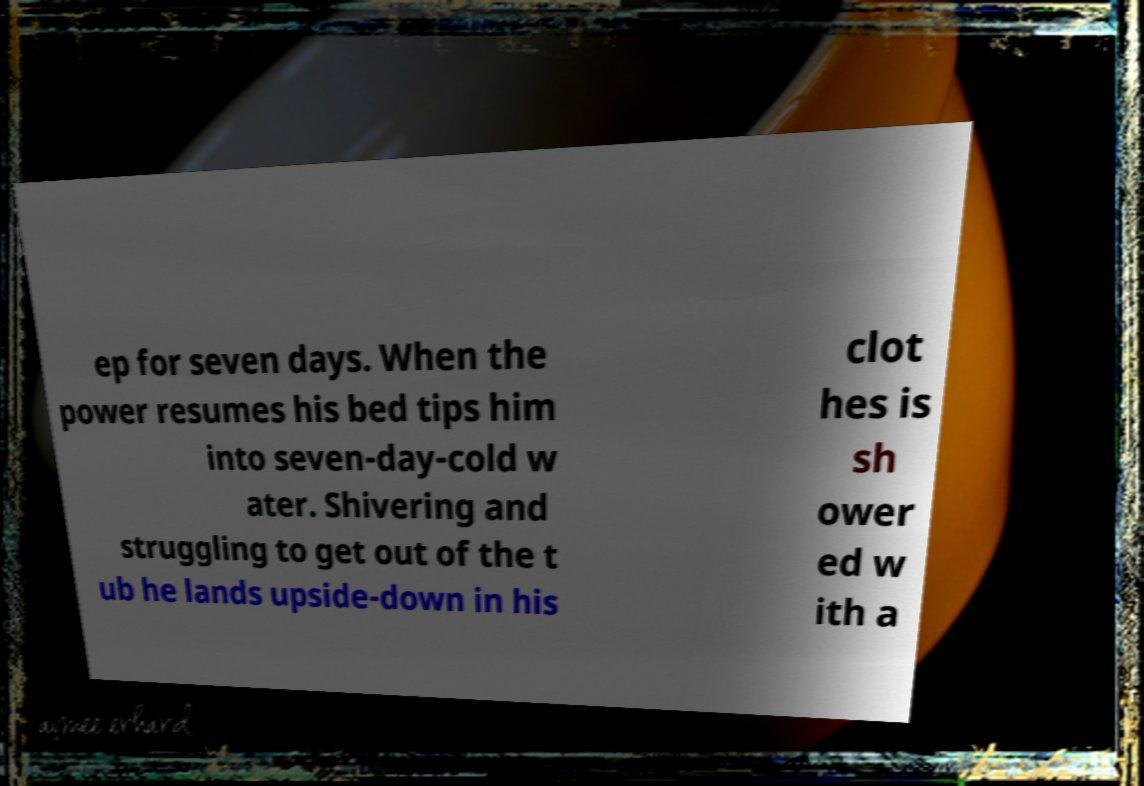I need the written content from this picture converted into text. Can you do that? ep for seven days. When the power resumes his bed tips him into seven-day-cold w ater. Shivering and struggling to get out of the t ub he lands upside-down in his clot hes is sh ower ed w ith a 